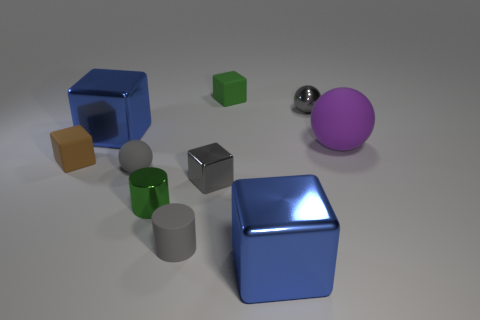There is a big thing to the left of the tiny green matte cube; what is its color?
Make the answer very short. Blue. What number of objects are either big blue metallic blocks that are behind the small brown object or metallic cylinders?
Your response must be concise. 2. What is the color of the rubber cylinder that is the same size as the green metal thing?
Give a very brief answer. Gray. Is the number of brown rubber blocks that are behind the green shiny cylinder greater than the number of large yellow cubes?
Provide a succinct answer. Yes. There is a object that is both to the left of the small green rubber cube and in front of the tiny green cylinder; what is its material?
Provide a short and direct response. Rubber. Is the color of the big metallic cube that is behind the purple ball the same as the large shiny thing on the right side of the green rubber cube?
Provide a succinct answer. Yes. How many other things are there of the same size as the brown object?
Provide a short and direct response. 6. Is there a rubber ball to the left of the gray thing right of the big metal object that is in front of the metallic cylinder?
Ensure brevity in your answer.  Yes. Does the tiny gray object that is on the left side of the green shiny cylinder have the same material as the green cylinder?
Provide a succinct answer. No. There is a tiny matte object that is the same shape as the tiny green metal thing; what is its color?
Provide a succinct answer. Gray. 